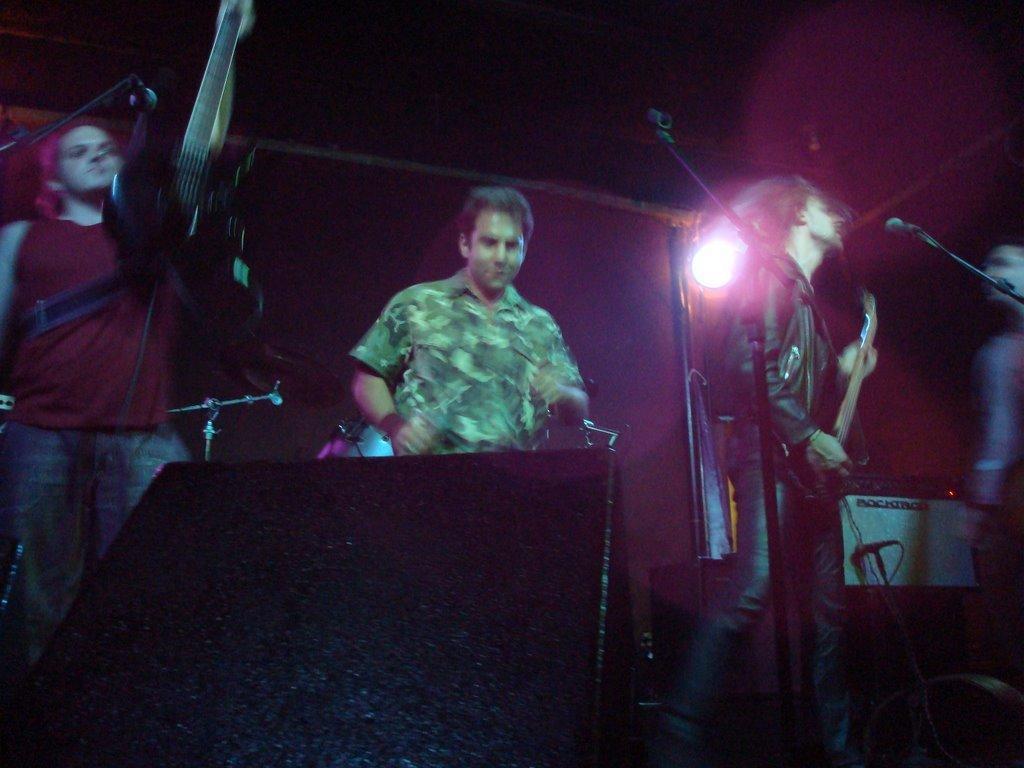Can you describe this image briefly? in this we picture we can a group of people performing the stage shoe of music, From the right a boy wearing black jacket is playing guitar , Middle person wearing military green shirt is singing and left boy is also singing , Behind we can see spot light and on the floor big black speaker and cables. 